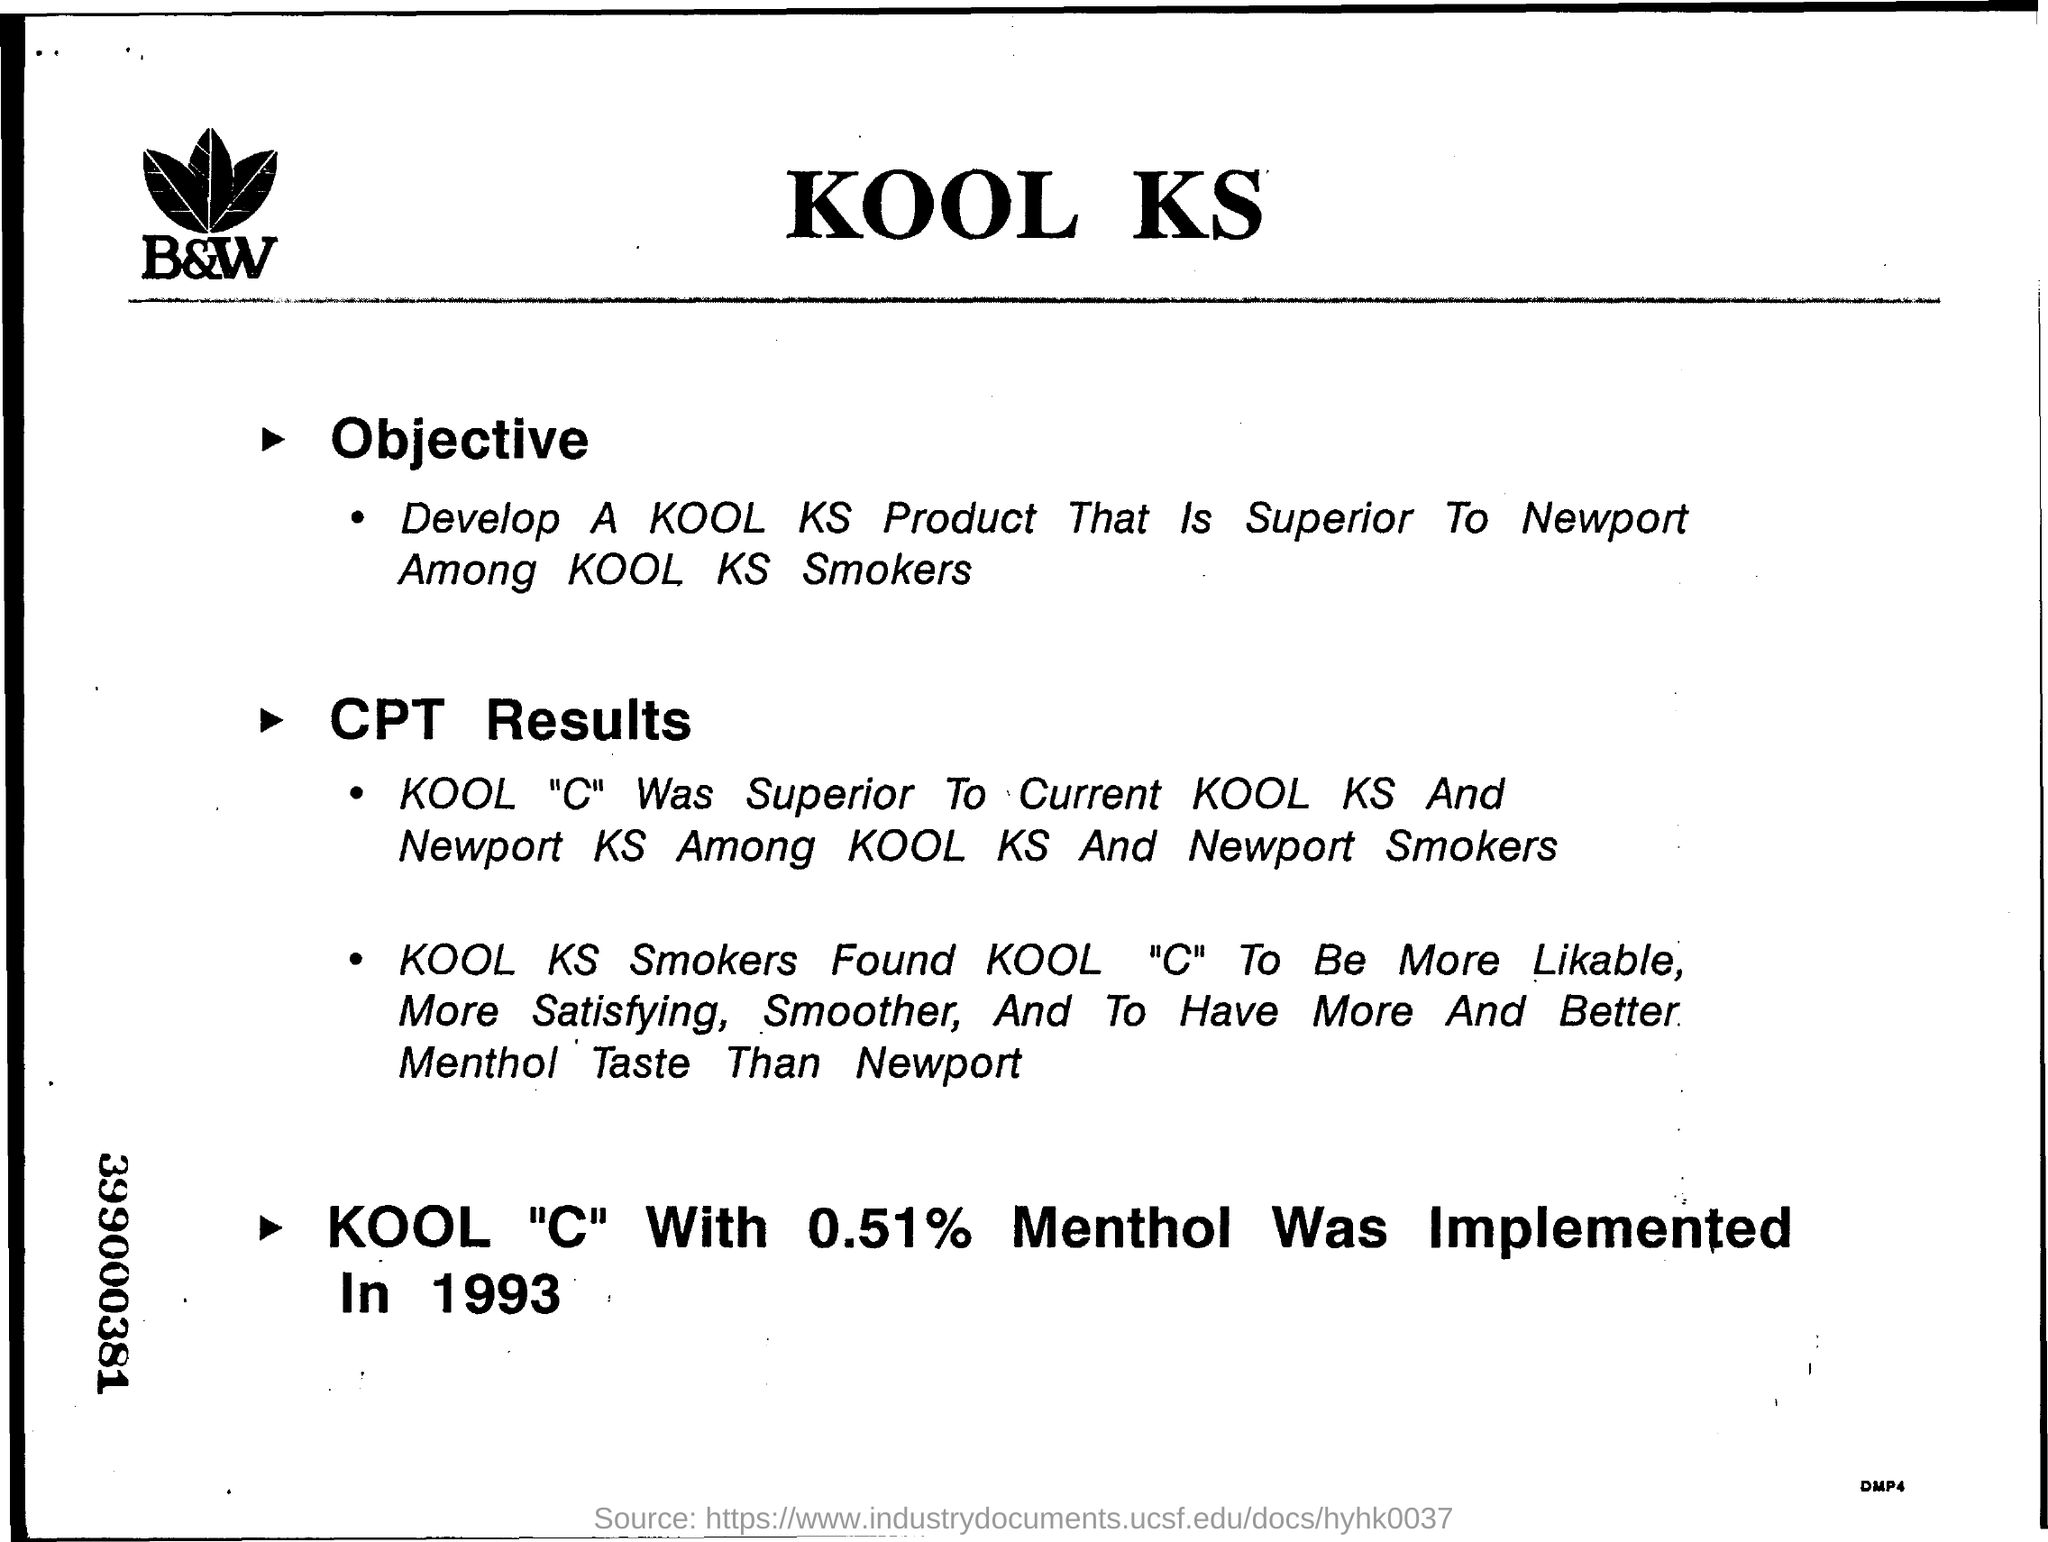What is the Objective of the document?
Offer a very short reply. Develop A KOOL KS Product That Is Superior To Newport Among KOOL KS Smokers. When was the KOOL "C" With 0.51% Menthol Implemented?
Offer a terse response. In 1993. Heading of the document?
Provide a short and direct response. Kool KS. What is the 9 digits number mentioned on the left margin?
Provide a succinct answer. 399000381. 